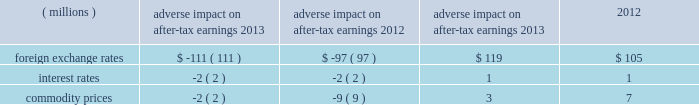Commodity prices risk : certain commodities the company uses in the production of its products are exposed to market price risks .
3m manages commodity price risks through negotiated supply contracts , price protection agreements and forward physical contracts .
The company uses commodity price swaps relative to natural gas as cash flow hedges of forecasted transactions to manage price volatility .
Generally , the length of time over which 3m hedges its exposure to the variability in future cash flows for its forecasted natural gas transactions is 12 months .
3m also enters into commodity price swaps that are not designated in hedge relationships to offset , in part , the impacts of fluctuations in costs associated with the use of certain precious metals .
The dollar equivalent gross notional amount of the company 2019s natural gas commodity price swaps designated as cash flow hedges and precious metal commodity price swaps not designated in hedge relationships were $ 19 million and $ 2 million , respectively , at december 31 , 2013 .
Value at risk : the value at risk analysis is performed annually .
A monte carlo simulation technique was used to test the company 2019s exposure to changes in currency rates , interest rates , and commodity prices and assess the risk of loss or benefit in after- tax earnings of financial instruments ( primarily debt ) , derivatives and underlying exposures outstanding at december 31 , 2013 .
The model ( third-party bank dataset ) used a 95 percent confidence level over a 12-month time horizon .
The exposure to changes in currency rates model used 18 currencies , interest rates related to four currencies , and commodity prices related to five commodities .
This model does not purport to represent what actually will be experienced by the company .
This model does not include certain hedge transactions , because the company believes their inclusion would not materially impact the results .
Foreign exchange rate risk of loss or benefit increased in 2013 , primarily due to increases in exposures , which is one of the key drivers in the valuation model .
Interest rate volatility remained stable in 2013 because interest rates are currently very low and are projected to remain low , based on forward rates .
The table summarizes the possible adverse and positive impacts to after-tax earnings related to these exposures .
Adverse impact on after-tax earnings positive impact on after-tax earnings .
In addition to the possible adverse and positive impacts discussed in the preceding table related to foreign exchange rates , recent historical information is as follows .
3m estimates that year-on-year currency effects , including hedging impacts , had the following effects on net income attributable to 3m : 2013 ( $ 74 million decrease ) and 2012 ( $ 103 million decrease ) .
This estimate includes the effect of translating profits from local currencies into u.s .
Dollars ; the impact of currency fluctuations on the transfer of goods between 3m operations in the united states and abroad ; and transaction gains and losses , including derivative instruments designed to reduce foreign currency exchange rate risks and the negative impact of swapping venezuelan bolivars into u.s .
Dollars .
3m estimates that year-on-year derivative and other transaction gains and losses had the following effects on net income attributable to 3m : 2013 ( $ 12 million decrease ) and 2012 ( $ 49 million increase ) .
An analysis of the global exposures related to purchased components and materials is performed at each year-end .
A one percent price change would result in a pre-tax cost or savings of approximately $ 76 million per year .
The global energy exposure is such that a 10 percent price change would result in a pre-tax cost or savings of approximately $ 45 million per .
In 2013 what was the combined adverse impact on after-tax earnings for foreign exchange rates in millions? 
Computations: (-111 + 119)
Answer: 8.0. 